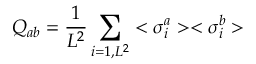<formula> <loc_0><loc_0><loc_500><loc_500>Q _ { a b } = { \frac { 1 } { L ^ { 2 } } } \sum _ { i = 1 , L ^ { 2 } } < \sigma _ { i } ^ { a } > < \sigma _ { i } ^ { b } ></formula> 